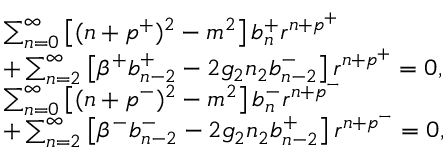Convert formula to latex. <formula><loc_0><loc_0><loc_500><loc_500>\begin{array} { r l } & { \sum _ { n = 0 } ^ { \infty } \left [ ( n + p ^ { + } ) ^ { 2 } - m ^ { 2 } \right ] b _ { n } ^ { + } r ^ { n + p ^ { + } } } \\ & { + \sum _ { n = 2 } ^ { \infty } \left [ \beta ^ { + } b _ { n - 2 } ^ { + } - 2 g _ { 2 } n _ { 2 } b _ { n - 2 } ^ { - } \right ] r ^ { n + p ^ { + } } = 0 , } \\ & { \sum _ { n = 0 } ^ { \infty } \left [ ( n + p ^ { - } ) ^ { 2 } - m ^ { 2 } \right ] b _ { n } ^ { - } r ^ { n + p ^ { - } } } \\ & { + \sum _ { n = 2 } ^ { \infty } \left [ \beta ^ { - } b _ { n - 2 } ^ { - } - 2 g _ { 2 } n _ { 2 } b _ { n - 2 } ^ { + } \right ] r ^ { n + p ^ { - } } = 0 , } \end{array}</formula> 